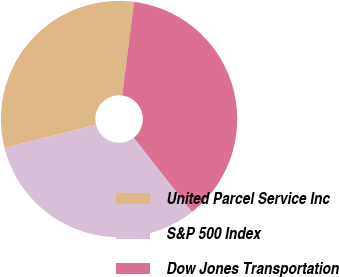<chart> <loc_0><loc_0><loc_500><loc_500><pie_chart><fcel>United Parcel Service Inc<fcel>S&P 500 Index<fcel>Dow Jones Transportation<nl><fcel>30.97%<fcel>31.66%<fcel>37.37%<nl></chart> 